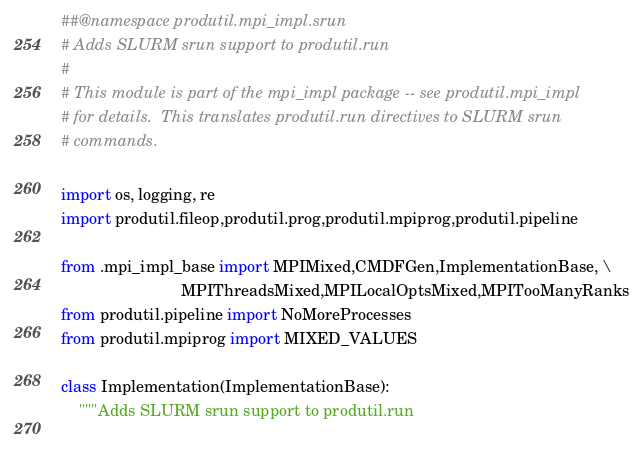<code> <loc_0><loc_0><loc_500><loc_500><_Python_>##@namespace produtil.mpi_impl.srun 
# Adds SLURM srun support to produtil.run
#
# This module is part of the mpi_impl package -- see produtil.mpi_impl
# for details.  This translates produtil.run directives to SLURM srun
# commands.

import os, logging, re
import produtil.fileop,produtil.prog,produtil.mpiprog,produtil.pipeline

from .mpi_impl_base import MPIMixed,CMDFGen,ImplementationBase, \
                           MPIThreadsMixed,MPILocalOptsMixed,MPITooManyRanks
from produtil.pipeline import NoMoreProcesses
from produtil.mpiprog import MIXED_VALUES

class Implementation(ImplementationBase):
    """Adds SLURM srun support to produtil.run
    </code> 